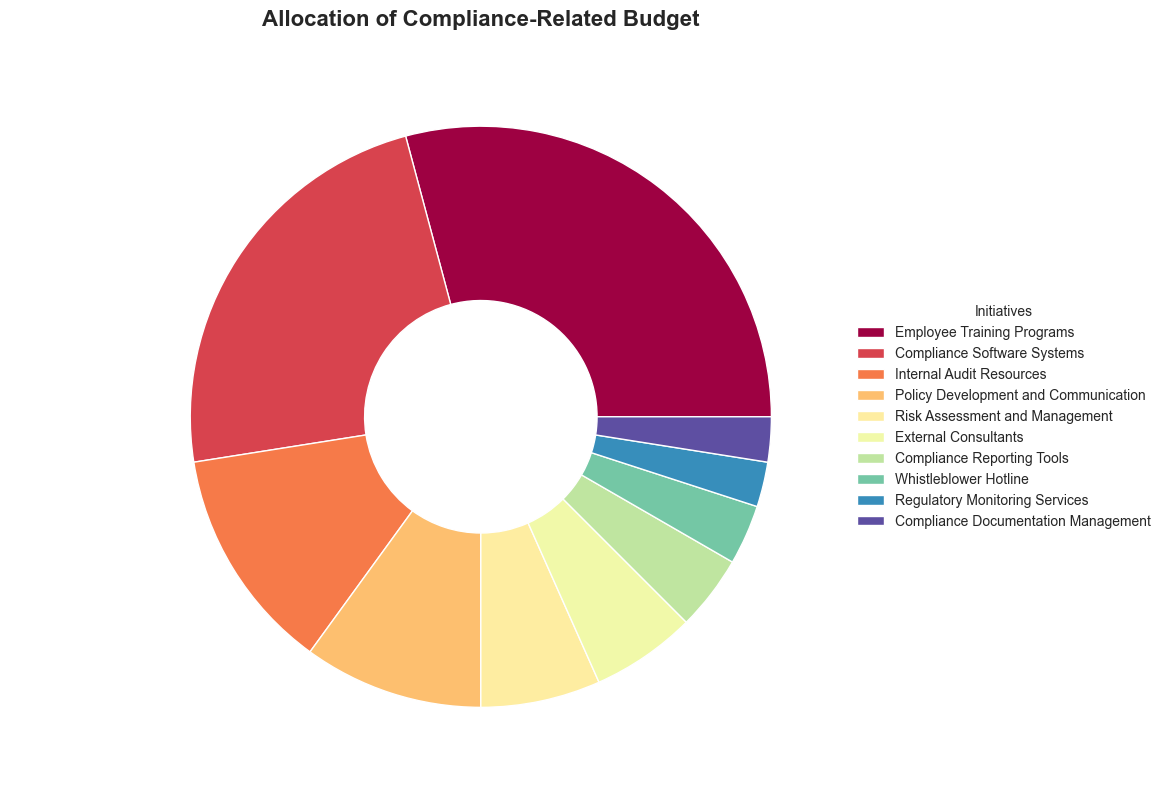Which initiative receives the largest percentage of the budget? The figure shows that Employee Training Programs receives the largest portion, which is indicated by the largest wedge in the pie chart.
Answer: Employee Training Programs What is the combined budget allocation percentage for Compliance Software Systems and Internal Audit Resources? Compliance Software Systems has 28%, and Internal Audit Resources has 15%. Summing these gives 28% + 15% = 43%.
Answer: 43% Out of Policy Development and Communication and Risk Assessment and Management, which initiative has a smaller budget allocation percentage? Policy Development and Communication is allocated 12%, while Risk Assessment and Management is allocated 8%. Thus, Risk Assessment and Management has a smaller allocation.
Answer: Risk Assessment and Management What is the total budget allocation for all initiatives receiving less than 10% each? Adding the budgets for initiatives receiving less than 10%: Risk Assessment and Management (8%), External Consultants (7%), Compliance Reporting Tools (5%), Whistleblower Hotline (4%), Regulatory Monitoring Services (3%), and Compliance Documentation Management (3%): 8% + 7% + 5% + 4% + 3% + 3% = 30%.
Answer: 30% What color is used to represent Employee Training Programs in the pie chart? The pie chart shows different colors for all initiatives, and the color used for Employee Training Programs can be identified as the largest wedge which is represented in purple hues.
Answer: Purple Which initiative has the smallest percentage of the budget allocation and what is that percentage? The smallest wedge in the pie chart represents Regulatory Monitoring Services and Compliance Documentation Management, both allocated 3%.
Answer: Regulatory Monitoring Services and Compliance Documentation Management, 3% How does the budget allocation for Compliance Reporting Tools compare to that for Whistleblower Hotline? Compliance Reporting Tools is allocated 5% of the budget, which is more than the 4% allocated to the Whistleblower Hotline.
Answer: Compliance Reporting Tools has a higher allocation If we consider the initiatives with the top three budget allocations, what is the total percentage allocated to them? Employee Training Programs (35%), Compliance Software Systems (28%), and Internal Audit Resources (15%). Summing these gives: 35% + 28% + 15% = 78%.
Answer: 78% 